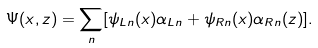Convert formula to latex. <formula><loc_0><loc_0><loc_500><loc_500>\Psi ( x , z ) = \sum _ { n } [ \psi _ { L n } ( x ) \alpha _ { L n } + \psi _ { R n } ( x ) \alpha _ { R n } ( z ) ] .</formula> 